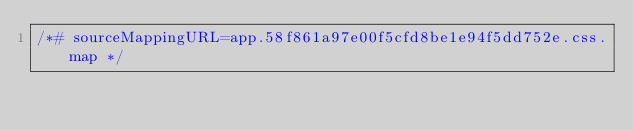Convert code to text. <code><loc_0><loc_0><loc_500><loc_500><_CSS_>/*# sourceMappingURL=app.58f861a97e00f5cfd8be1e94f5dd752e.css.map */</code> 